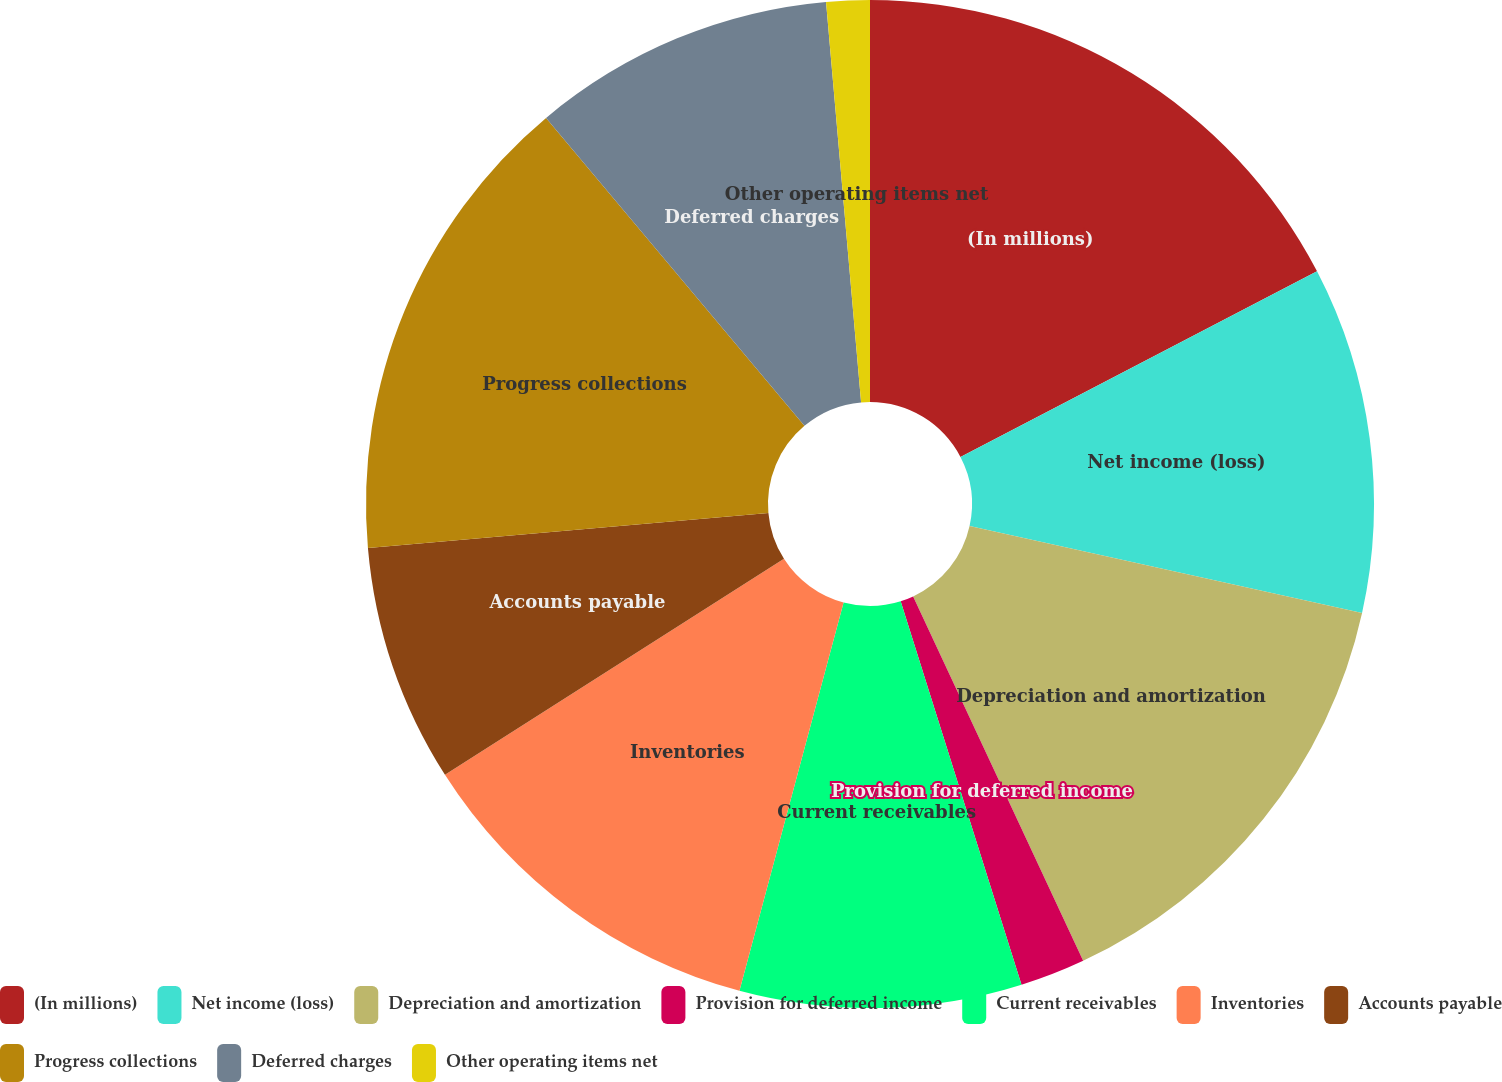Convert chart to OTSL. <chart><loc_0><loc_0><loc_500><loc_500><pie_chart><fcel>(In millions)<fcel>Net income (loss)<fcel>Depreciation and amortization<fcel>Provision for deferred income<fcel>Current receivables<fcel>Inventories<fcel>Accounts payable<fcel>Progress collections<fcel>Deferred charges<fcel>Other operating items net<nl><fcel>17.36%<fcel>11.11%<fcel>14.58%<fcel>2.09%<fcel>9.03%<fcel>11.8%<fcel>7.64%<fcel>15.28%<fcel>9.72%<fcel>1.39%<nl></chart> 